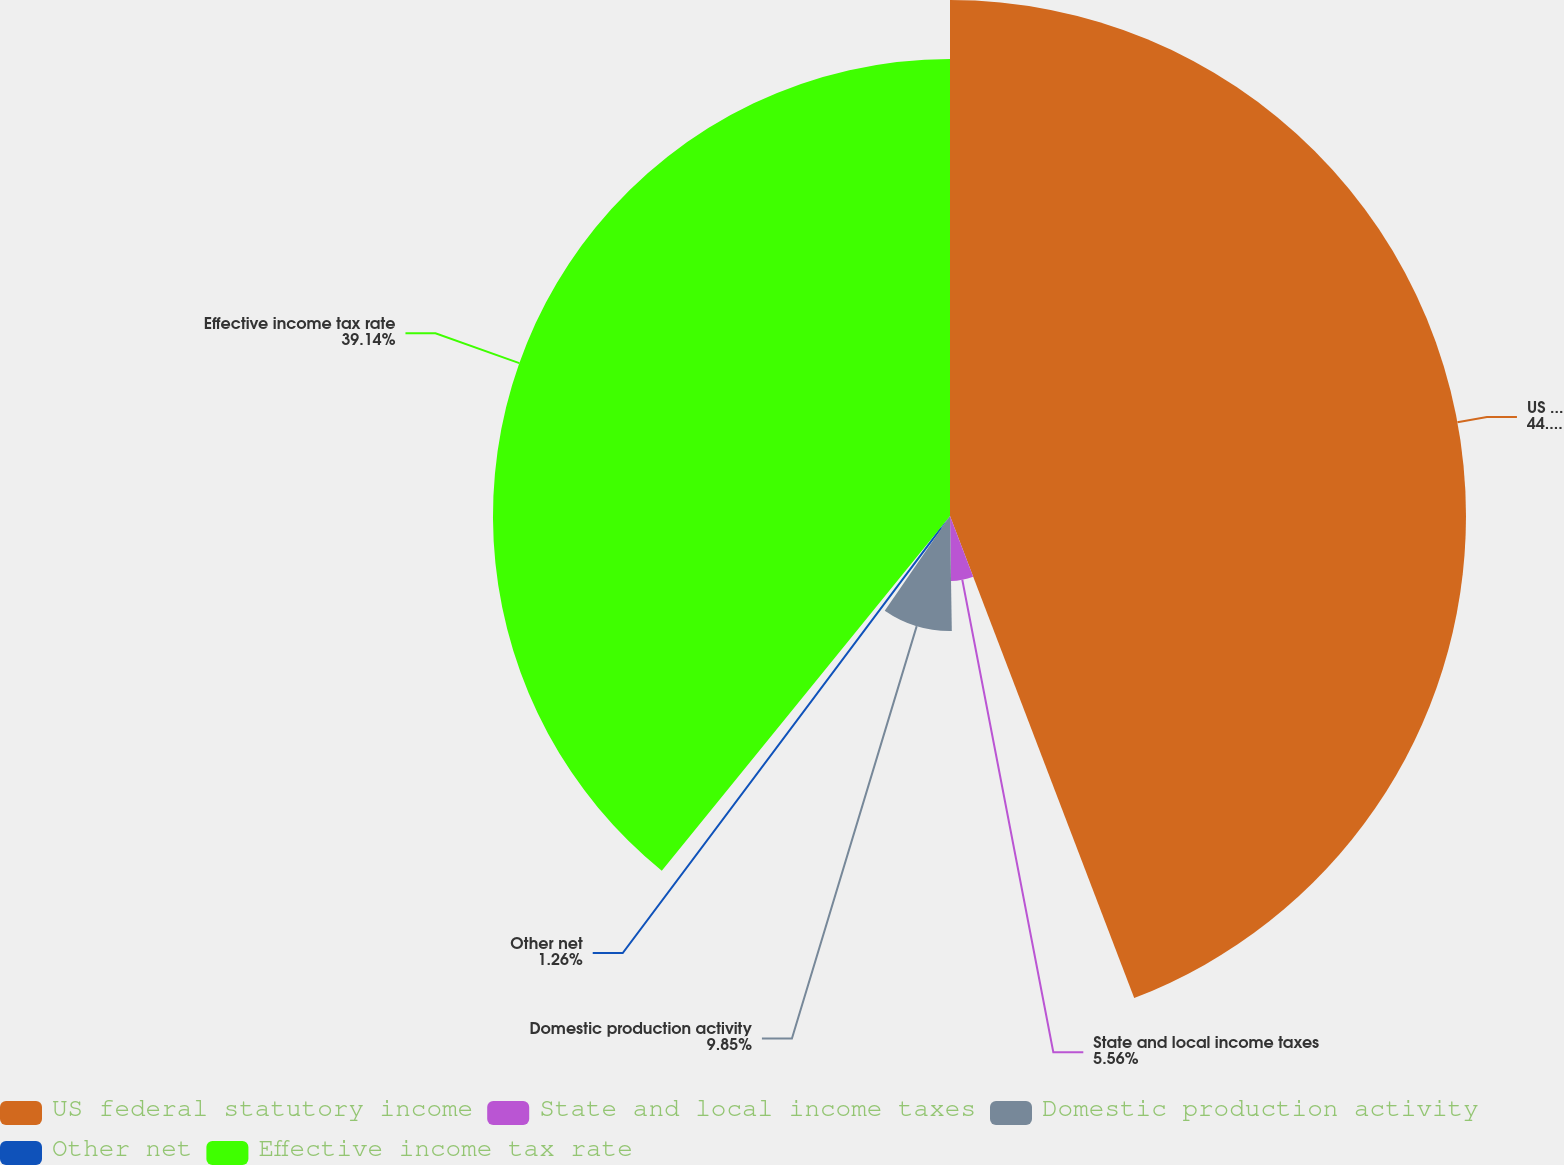<chart> <loc_0><loc_0><loc_500><loc_500><pie_chart><fcel>US federal statutory income<fcel>State and local income taxes<fcel>Domestic production activity<fcel>Other net<fcel>Effective income tax rate<nl><fcel>44.19%<fcel>5.56%<fcel>9.85%<fcel>1.26%<fcel>39.14%<nl></chart> 